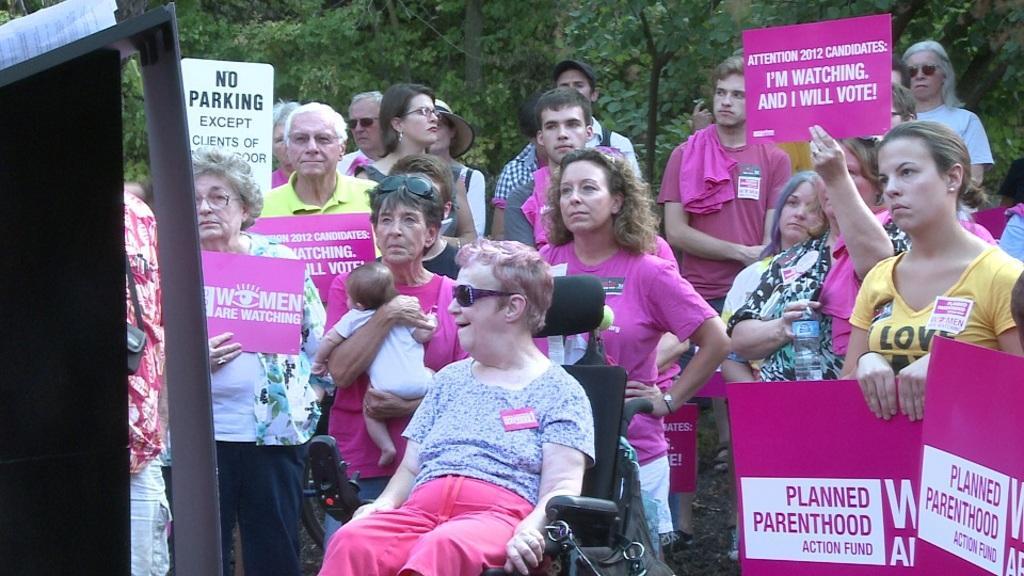How would you summarize this image in a sentence or two? In this picture we can see a woman sitting on a chair. There are a few people holding posters in their hands and standing. We can see a woman carrying a baby. There are a few trees visible in the background. 